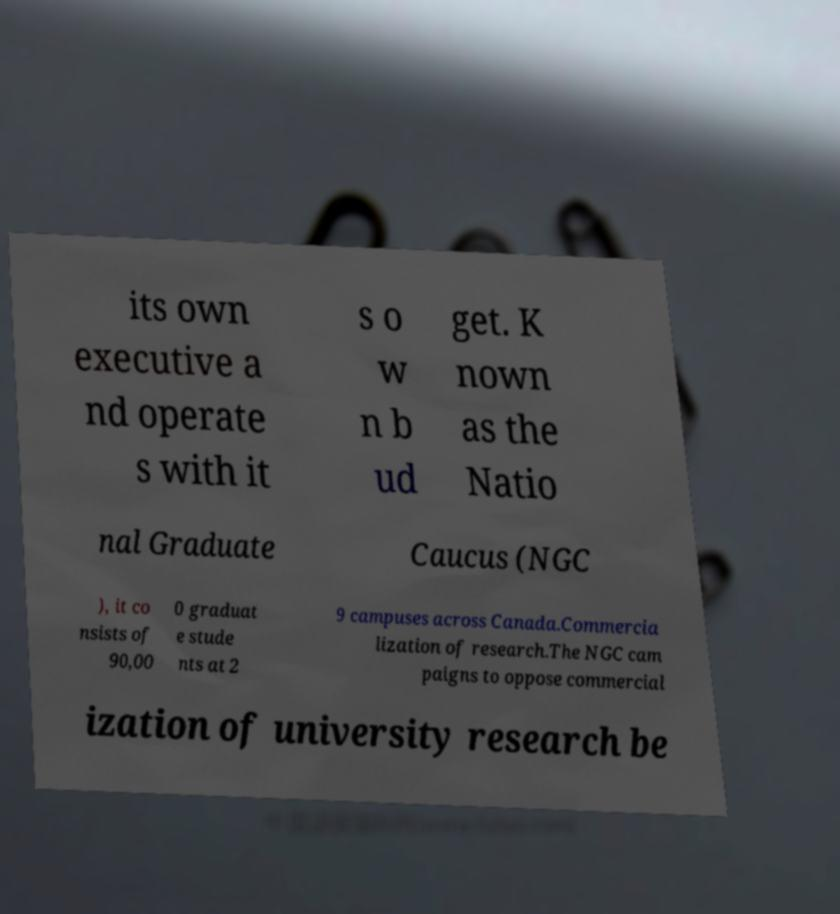Could you extract and type out the text from this image? its own executive a nd operate s with it s o w n b ud get. K nown as the Natio nal Graduate Caucus (NGC ), it co nsists of 90,00 0 graduat e stude nts at 2 9 campuses across Canada.Commercia lization of research.The NGC cam paigns to oppose commercial ization of university research be 